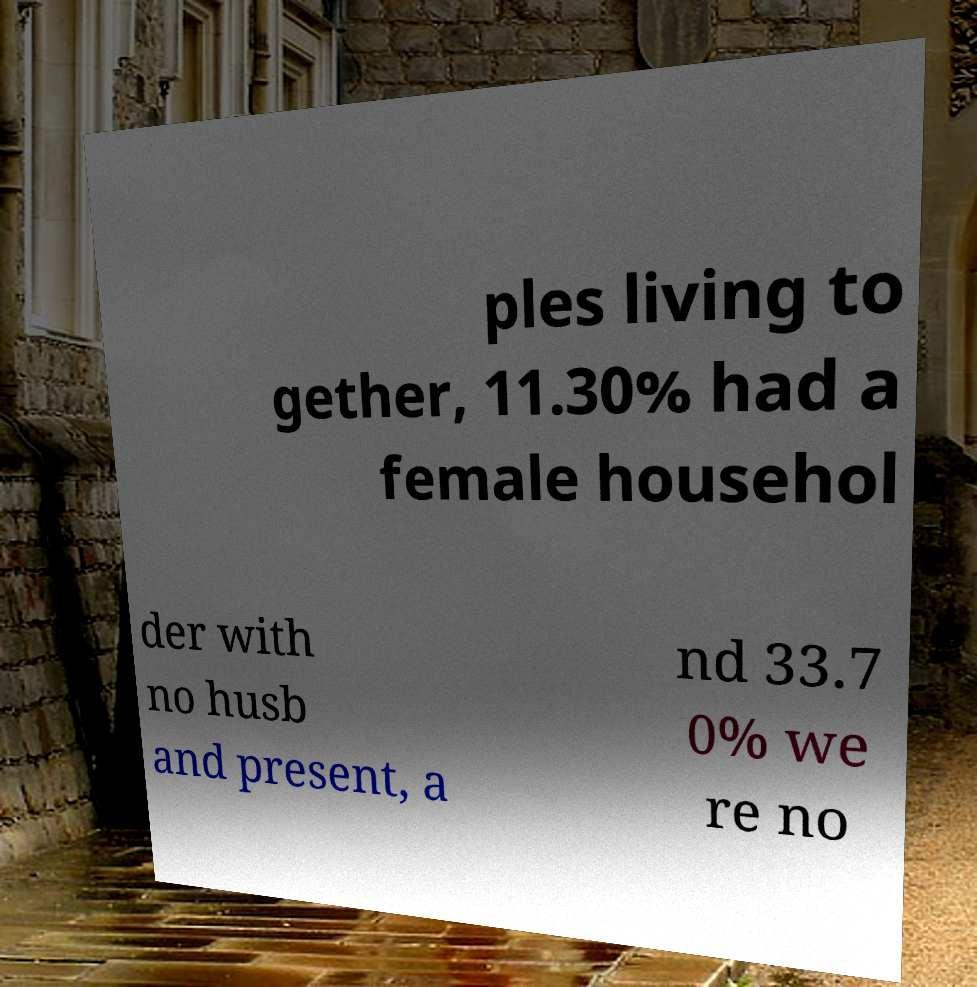Can you accurately transcribe the text from the provided image for me? ples living to gether, 11.30% had a female househol der with no husb and present, a nd 33.7 0% we re no 